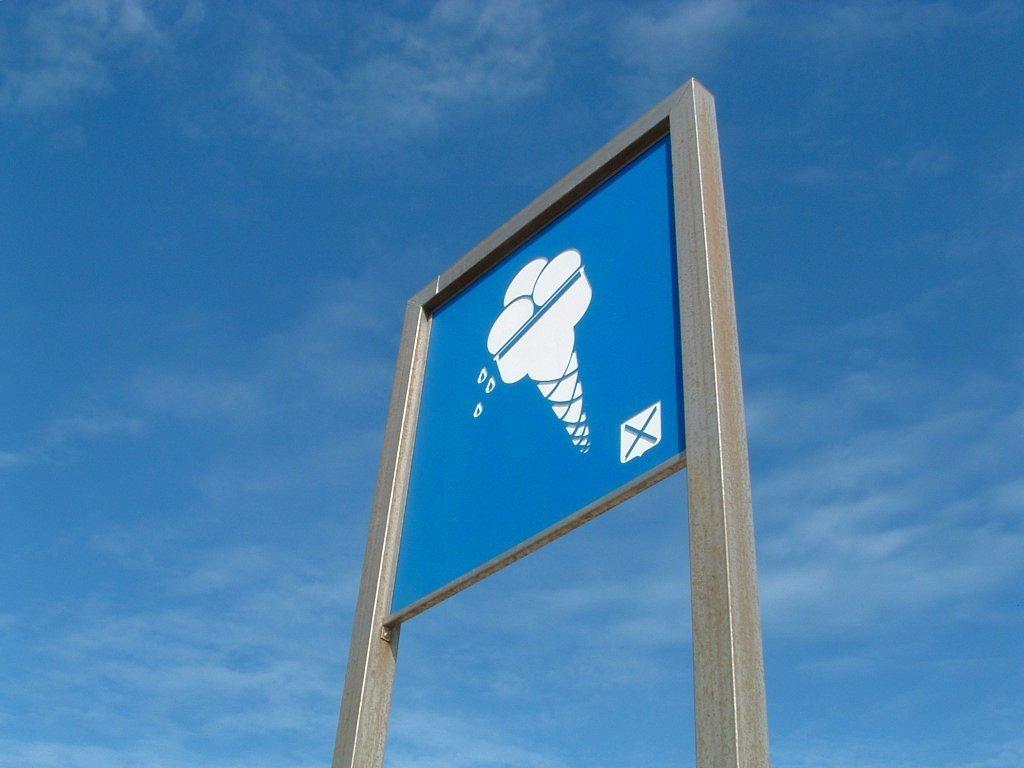Describe this image in one or two sentences. This image is taken outdoors. At the top of the image there is the sky with clouds. In the middle of the image there is signboard with an image of ice cream and a cross symbol on it. 